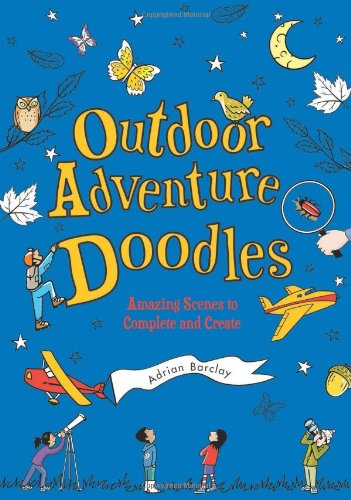Is this a christianity book? No, this book focuses on general outdoor adventures and doodling activities, and does not specifically address or promote Christianity. 